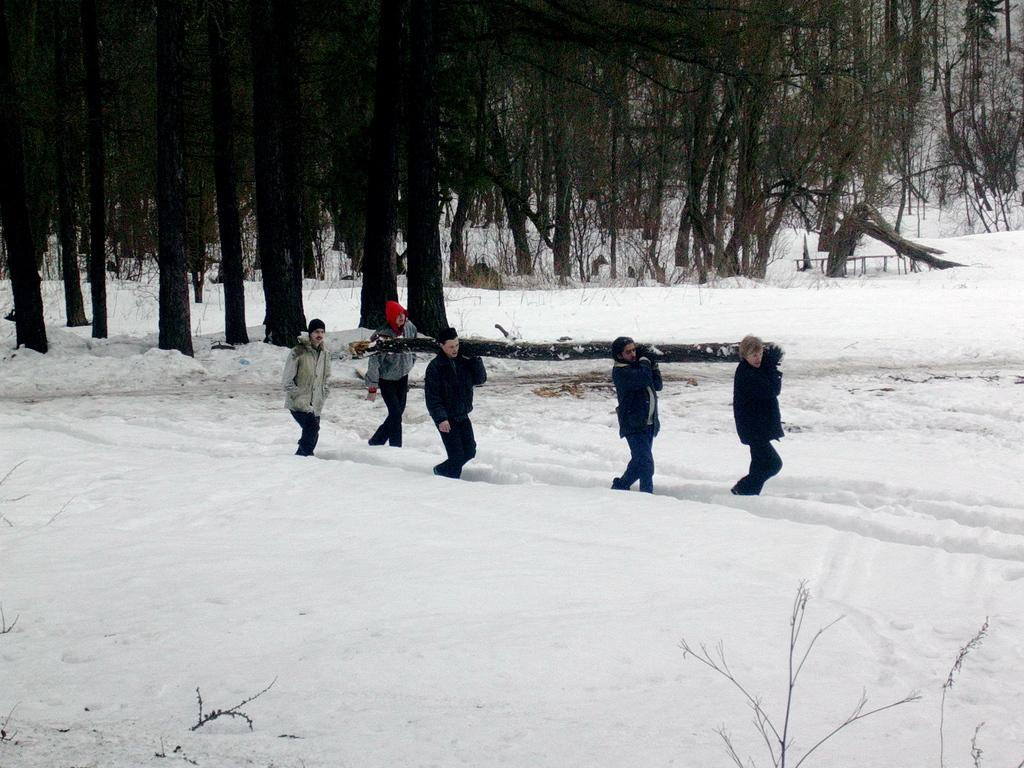Who or what is present in the image? There are people in the image. What are the people doing in the image? The people are holding a trunk. What is the surface they are standing on? The people are standing on a snow floor. What type of vegetation can be seen in the image? There are trees and plants in the image. What type of deer can be seen interacting with the people in the image? There is no deer present in the image; it only features people holding a trunk on a snow floor. What subject is the person in the image teaching to the others? There is no indication of teaching or any specific subject in the image. 